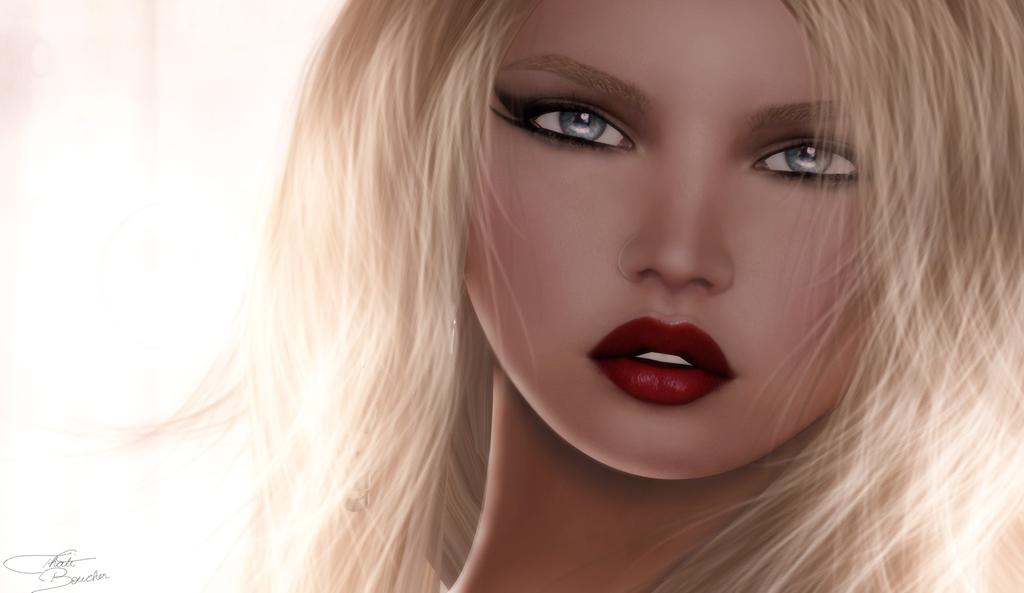What is the main subject of the image? The main subject of the image is an animated picture of a woman. Can you describe any additional features of the image? There is a watermark on the left side of the image. What type of noise can be heard coming from the tub in the image? There is no tub present in the image, so it is not possible to determine what, if any, noise might be heard. 